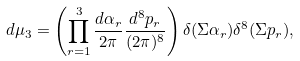<formula> <loc_0><loc_0><loc_500><loc_500>d \mu _ { 3 } = \left ( \prod _ { r = 1 } ^ { 3 } \frac { d \alpha _ { r } } { 2 \pi } \frac { d ^ { 8 } p _ { r } } { ( 2 \pi ) ^ { 8 } } \right ) \delta ( \Sigma \alpha _ { r } ) \delta ^ { 8 } ( \Sigma p _ { r } ) ,</formula> 